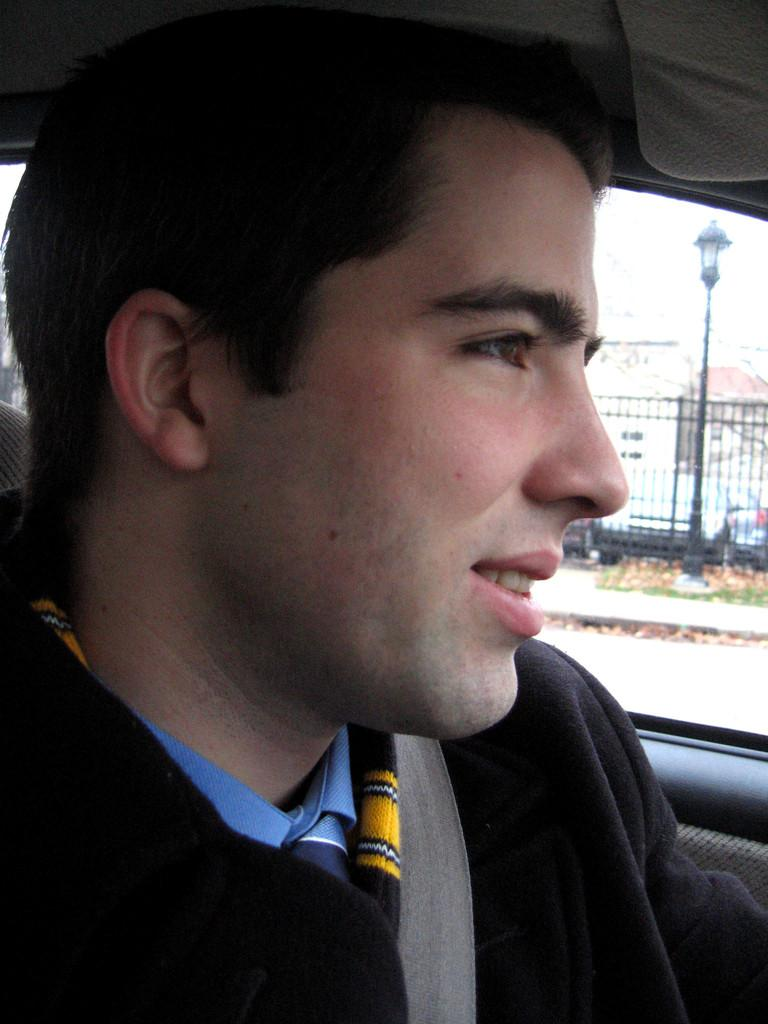What is the person in the image doing? There is a person sitting inside the car in the image. Is the person taking any safety precautions while sitting in the car? Yes, the person is wearing a seat belt. What can be seen behind the car in the image? There is a street light at the back side of the car. What type of structure is visible in the background of the image? There is a metal grill in the background of the image. What type of advice is the person's grandmother giving in the image? There is no grandmother present in the image, so it is not possible to determine what advice might be given. 